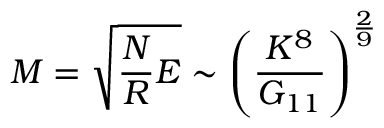Convert formula to latex. <formula><loc_0><loc_0><loc_500><loc_500>M = \sqrt { \frac { N } { R } E } \sim \left ( \frac { K ^ { 8 } } { G _ { 1 1 } } \right ) ^ { \frac { 2 } { 9 } }</formula> 